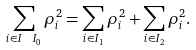Convert formula to latex. <formula><loc_0><loc_0><loc_500><loc_500>\sum _ { i \in I \ I _ { 0 } } \rho _ { i } ^ { 2 } = \sum _ { i \in I _ { 1 } } \rho _ { i } ^ { 2 } + \sum _ { i \in I _ { 2 } } \rho _ { i } ^ { 2 } .</formula> 